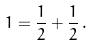<formula> <loc_0><loc_0><loc_500><loc_500>1 = \frac { 1 } { 2 } + \frac { 1 } { 2 } \, .</formula> 